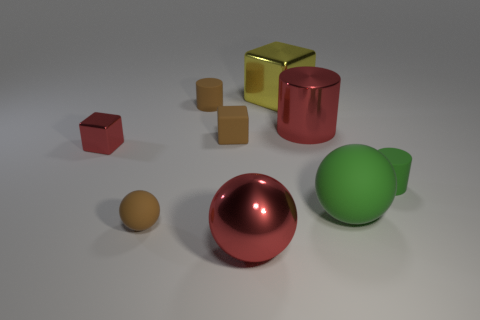Subtract 1 balls. How many balls are left? 2 Subtract all cylinders. How many objects are left? 6 Subtract 0 blue blocks. How many objects are left? 9 Subtract all matte objects. Subtract all shiny spheres. How many objects are left? 3 Add 2 small brown balls. How many small brown balls are left? 3 Add 2 tiny green objects. How many tiny green objects exist? 3 